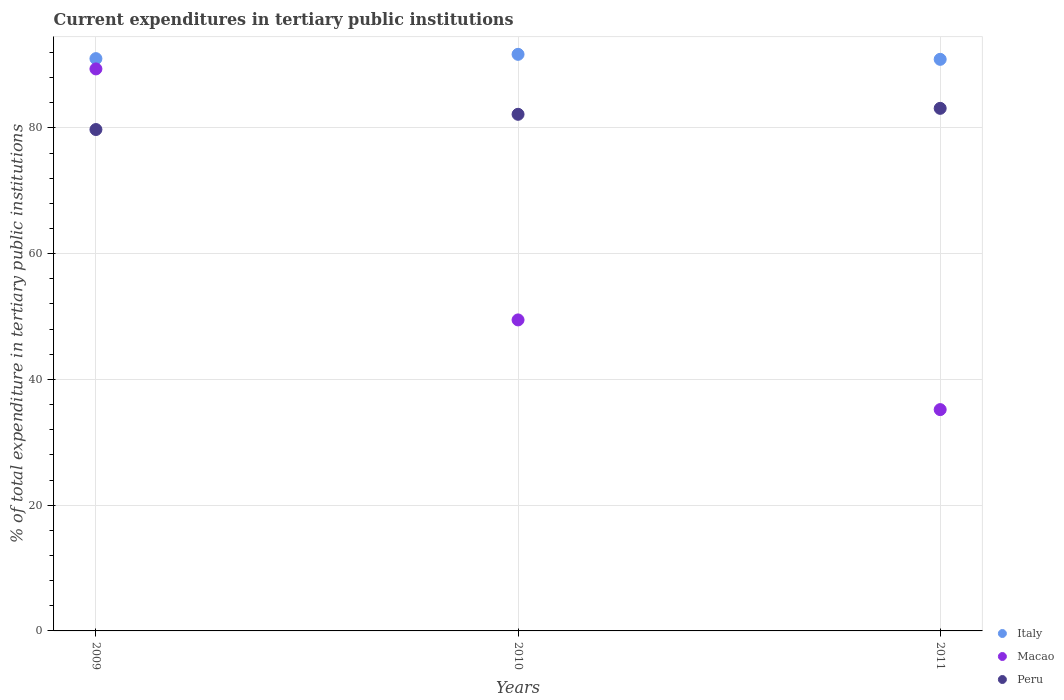How many different coloured dotlines are there?
Your response must be concise. 3. What is the current expenditures in tertiary public institutions in Italy in 2009?
Ensure brevity in your answer.  91.03. Across all years, what is the maximum current expenditures in tertiary public institutions in Macao?
Your response must be concise. 89.39. Across all years, what is the minimum current expenditures in tertiary public institutions in Peru?
Offer a terse response. 79.75. What is the total current expenditures in tertiary public institutions in Peru in the graph?
Give a very brief answer. 245.04. What is the difference between the current expenditures in tertiary public institutions in Italy in 2009 and that in 2011?
Offer a terse response. 0.11. What is the difference between the current expenditures in tertiary public institutions in Italy in 2011 and the current expenditures in tertiary public institutions in Macao in 2009?
Provide a succinct answer. 1.52. What is the average current expenditures in tertiary public institutions in Italy per year?
Your response must be concise. 91.22. In the year 2010, what is the difference between the current expenditures in tertiary public institutions in Macao and current expenditures in tertiary public institutions in Italy?
Your answer should be compact. -42.24. What is the ratio of the current expenditures in tertiary public institutions in Peru in 2009 to that in 2010?
Offer a terse response. 0.97. Is the current expenditures in tertiary public institutions in Macao in 2009 less than that in 2010?
Keep it short and to the point. No. Is the difference between the current expenditures in tertiary public institutions in Macao in 2009 and 2010 greater than the difference between the current expenditures in tertiary public institutions in Italy in 2009 and 2010?
Provide a succinct answer. Yes. What is the difference between the highest and the second highest current expenditures in tertiary public institutions in Macao?
Provide a short and direct response. 39.92. What is the difference between the highest and the lowest current expenditures in tertiary public institutions in Peru?
Ensure brevity in your answer.  3.37. Is the current expenditures in tertiary public institutions in Peru strictly greater than the current expenditures in tertiary public institutions in Macao over the years?
Your answer should be very brief. No. What is the difference between two consecutive major ticks on the Y-axis?
Ensure brevity in your answer.  20. Does the graph contain grids?
Give a very brief answer. Yes. Where does the legend appear in the graph?
Provide a succinct answer. Bottom right. How many legend labels are there?
Ensure brevity in your answer.  3. What is the title of the graph?
Provide a short and direct response. Current expenditures in tertiary public institutions. What is the label or title of the Y-axis?
Give a very brief answer. % of total expenditure in tertiary public institutions. What is the % of total expenditure in tertiary public institutions of Italy in 2009?
Your answer should be compact. 91.03. What is the % of total expenditure in tertiary public institutions in Macao in 2009?
Offer a very short reply. 89.39. What is the % of total expenditure in tertiary public institutions in Peru in 2009?
Offer a very short reply. 79.75. What is the % of total expenditure in tertiary public institutions in Italy in 2010?
Give a very brief answer. 91.71. What is the % of total expenditure in tertiary public institutions in Macao in 2010?
Keep it short and to the point. 49.47. What is the % of total expenditure in tertiary public institutions in Peru in 2010?
Give a very brief answer. 82.17. What is the % of total expenditure in tertiary public institutions in Italy in 2011?
Give a very brief answer. 90.92. What is the % of total expenditure in tertiary public institutions in Macao in 2011?
Offer a very short reply. 35.2. What is the % of total expenditure in tertiary public institutions in Peru in 2011?
Ensure brevity in your answer.  83.12. Across all years, what is the maximum % of total expenditure in tertiary public institutions of Italy?
Make the answer very short. 91.71. Across all years, what is the maximum % of total expenditure in tertiary public institutions of Macao?
Your answer should be very brief. 89.39. Across all years, what is the maximum % of total expenditure in tertiary public institutions in Peru?
Keep it short and to the point. 83.12. Across all years, what is the minimum % of total expenditure in tertiary public institutions of Italy?
Your answer should be compact. 90.92. Across all years, what is the minimum % of total expenditure in tertiary public institutions in Macao?
Your answer should be very brief. 35.2. Across all years, what is the minimum % of total expenditure in tertiary public institutions of Peru?
Offer a very short reply. 79.75. What is the total % of total expenditure in tertiary public institutions in Italy in the graph?
Offer a very short reply. 273.65. What is the total % of total expenditure in tertiary public institutions in Macao in the graph?
Provide a short and direct response. 174.06. What is the total % of total expenditure in tertiary public institutions of Peru in the graph?
Ensure brevity in your answer.  245.04. What is the difference between the % of total expenditure in tertiary public institutions in Italy in 2009 and that in 2010?
Make the answer very short. -0.68. What is the difference between the % of total expenditure in tertiary public institutions of Macao in 2009 and that in 2010?
Give a very brief answer. 39.92. What is the difference between the % of total expenditure in tertiary public institutions in Peru in 2009 and that in 2010?
Provide a succinct answer. -2.42. What is the difference between the % of total expenditure in tertiary public institutions in Italy in 2009 and that in 2011?
Make the answer very short. 0.11. What is the difference between the % of total expenditure in tertiary public institutions of Macao in 2009 and that in 2011?
Your answer should be compact. 54.19. What is the difference between the % of total expenditure in tertiary public institutions in Peru in 2009 and that in 2011?
Provide a succinct answer. -3.37. What is the difference between the % of total expenditure in tertiary public institutions of Italy in 2010 and that in 2011?
Make the answer very short. 0.8. What is the difference between the % of total expenditure in tertiary public institutions of Macao in 2010 and that in 2011?
Provide a succinct answer. 14.27. What is the difference between the % of total expenditure in tertiary public institutions in Peru in 2010 and that in 2011?
Your response must be concise. -0.95. What is the difference between the % of total expenditure in tertiary public institutions in Italy in 2009 and the % of total expenditure in tertiary public institutions in Macao in 2010?
Offer a very short reply. 41.56. What is the difference between the % of total expenditure in tertiary public institutions of Italy in 2009 and the % of total expenditure in tertiary public institutions of Peru in 2010?
Ensure brevity in your answer.  8.86. What is the difference between the % of total expenditure in tertiary public institutions in Macao in 2009 and the % of total expenditure in tertiary public institutions in Peru in 2010?
Keep it short and to the point. 7.22. What is the difference between the % of total expenditure in tertiary public institutions in Italy in 2009 and the % of total expenditure in tertiary public institutions in Macao in 2011?
Ensure brevity in your answer.  55.83. What is the difference between the % of total expenditure in tertiary public institutions of Italy in 2009 and the % of total expenditure in tertiary public institutions of Peru in 2011?
Make the answer very short. 7.91. What is the difference between the % of total expenditure in tertiary public institutions of Macao in 2009 and the % of total expenditure in tertiary public institutions of Peru in 2011?
Your answer should be compact. 6.27. What is the difference between the % of total expenditure in tertiary public institutions of Italy in 2010 and the % of total expenditure in tertiary public institutions of Macao in 2011?
Your response must be concise. 56.51. What is the difference between the % of total expenditure in tertiary public institutions in Italy in 2010 and the % of total expenditure in tertiary public institutions in Peru in 2011?
Your response must be concise. 8.59. What is the difference between the % of total expenditure in tertiary public institutions in Macao in 2010 and the % of total expenditure in tertiary public institutions in Peru in 2011?
Provide a short and direct response. -33.65. What is the average % of total expenditure in tertiary public institutions of Italy per year?
Your response must be concise. 91.22. What is the average % of total expenditure in tertiary public institutions of Macao per year?
Provide a short and direct response. 58.02. What is the average % of total expenditure in tertiary public institutions of Peru per year?
Ensure brevity in your answer.  81.68. In the year 2009, what is the difference between the % of total expenditure in tertiary public institutions in Italy and % of total expenditure in tertiary public institutions in Macao?
Make the answer very short. 1.64. In the year 2009, what is the difference between the % of total expenditure in tertiary public institutions of Italy and % of total expenditure in tertiary public institutions of Peru?
Keep it short and to the point. 11.28. In the year 2009, what is the difference between the % of total expenditure in tertiary public institutions in Macao and % of total expenditure in tertiary public institutions in Peru?
Offer a very short reply. 9.64. In the year 2010, what is the difference between the % of total expenditure in tertiary public institutions in Italy and % of total expenditure in tertiary public institutions in Macao?
Give a very brief answer. 42.24. In the year 2010, what is the difference between the % of total expenditure in tertiary public institutions of Italy and % of total expenditure in tertiary public institutions of Peru?
Offer a terse response. 9.54. In the year 2010, what is the difference between the % of total expenditure in tertiary public institutions in Macao and % of total expenditure in tertiary public institutions in Peru?
Give a very brief answer. -32.7. In the year 2011, what is the difference between the % of total expenditure in tertiary public institutions of Italy and % of total expenditure in tertiary public institutions of Macao?
Give a very brief answer. 55.71. In the year 2011, what is the difference between the % of total expenditure in tertiary public institutions in Italy and % of total expenditure in tertiary public institutions in Peru?
Your answer should be compact. 7.79. In the year 2011, what is the difference between the % of total expenditure in tertiary public institutions in Macao and % of total expenditure in tertiary public institutions in Peru?
Your answer should be compact. -47.92. What is the ratio of the % of total expenditure in tertiary public institutions of Italy in 2009 to that in 2010?
Make the answer very short. 0.99. What is the ratio of the % of total expenditure in tertiary public institutions in Macao in 2009 to that in 2010?
Your response must be concise. 1.81. What is the ratio of the % of total expenditure in tertiary public institutions of Peru in 2009 to that in 2010?
Offer a very short reply. 0.97. What is the ratio of the % of total expenditure in tertiary public institutions of Italy in 2009 to that in 2011?
Ensure brevity in your answer.  1. What is the ratio of the % of total expenditure in tertiary public institutions in Macao in 2009 to that in 2011?
Ensure brevity in your answer.  2.54. What is the ratio of the % of total expenditure in tertiary public institutions of Peru in 2009 to that in 2011?
Keep it short and to the point. 0.96. What is the ratio of the % of total expenditure in tertiary public institutions in Italy in 2010 to that in 2011?
Your response must be concise. 1.01. What is the ratio of the % of total expenditure in tertiary public institutions in Macao in 2010 to that in 2011?
Your answer should be very brief. 1.41. What is the difference between the highest and the second highest % of total expenditure in tertiary public institutions of Italy?
Keep it short and to the point. 0.68. What is the difference between the highest and the second highest % of total expenditure in tertiary public institutions in Macao?
Give a very brief answer. 39.92. What is the difference between the highest and the second highest % of total expenditure in tertiary public institutions in Peru?
Give a very brief answer. 0.95. What is the difference between the highest and the lowest % of total expenditure in tertiary public institutions in Italy?
Your answer should be compact. 0.8. What is the difference between the highest and the lowest % of total expenditure in tertiary public institutions of Macao?
Provide a succinct answer. 54.19. What is the difference between the highest and the lowest % of total expenditure in tertiary public institutions of Peru?
Offer a terse response. 3.37. 